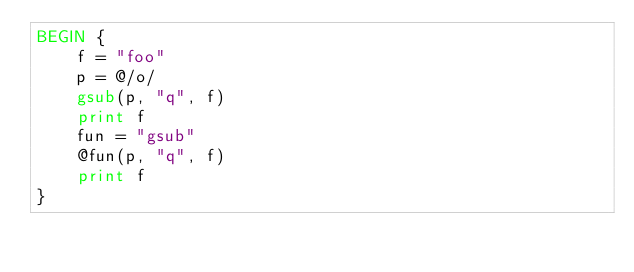<code> <loc_0><loc_0><loc_500><loc_500><_Awk_>BEGIN {
	f = "foo"
	p = @/o/
	gsub(p, "q", f)
	print f
	fun = "gsub"
	@fun(p, "q", f)
	print f
}
</code> 